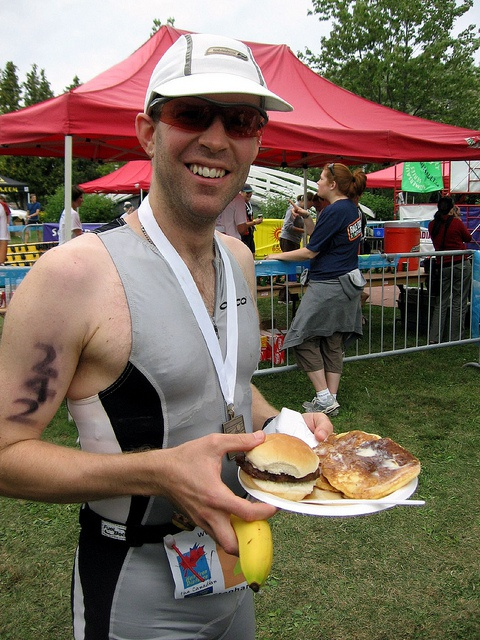Describe the objects in this image and their specific colors. I can see people in lavender, black, darkgray, and gray tones, people in lavender, black, gray, and maroon tones, sandwich in lavender, tan, and gray tones, sandwich in lavender, tan, black, and maroon tones, and people in lavender, black, maroon, and gray tones in this image. 